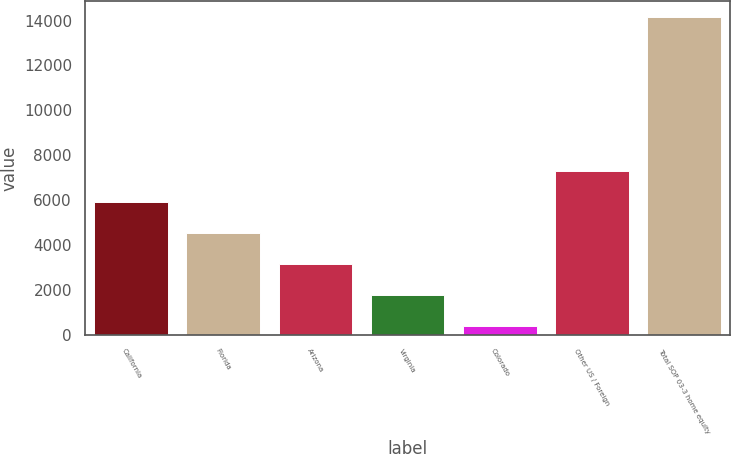Convert chart. <chart><loc_0><loc_0><loc_500><loc_500><bar_chart><fcel>California<fcel>Florida<fcel>Arizona<fcel>Virginia<fcel>Colorado<fcel>Other US / Foreign<fcel>Total SOP 03-3 home equity<nl><fcel>5907.6<fcel>4531.7<fcel>3155.8<fcel>1779.9<fcel>404<fcel>7283.5<fcel>14163<nl></chart> 